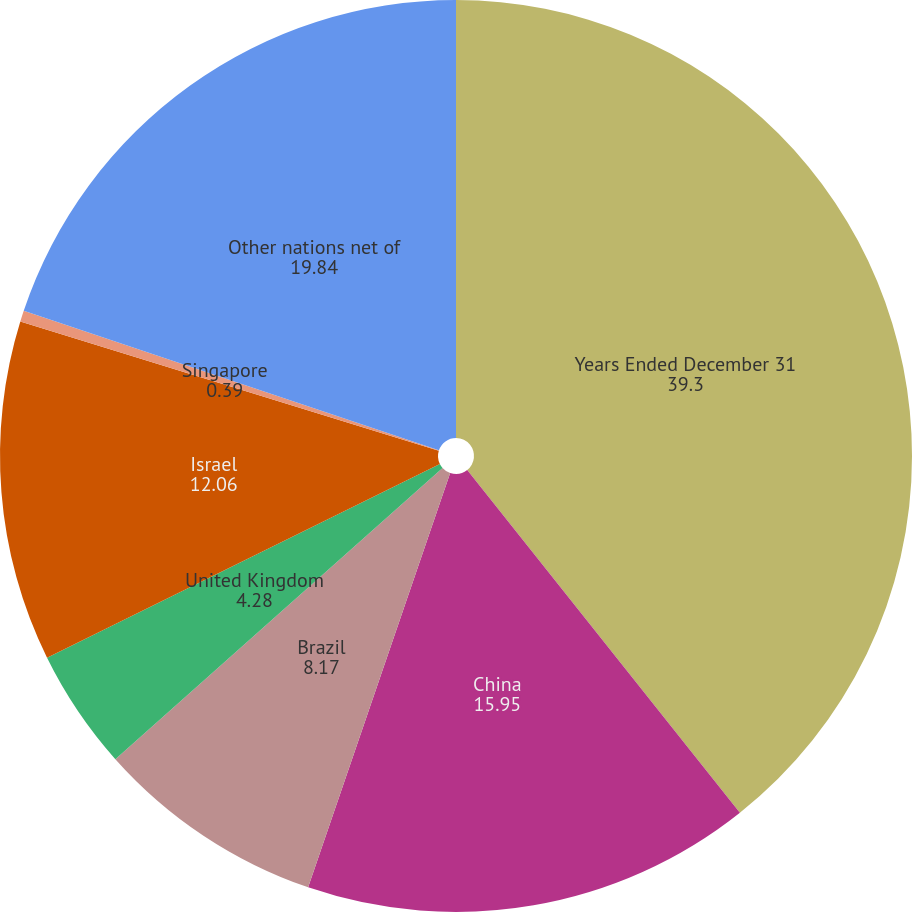Convert chart to OTSL. <chart><loc_0><loc_0><loc_500><loc_500><pie_chart><fcel>Years Ended December 31<fcel>China<fcel>Brazil<fcel>United Kingdom<fcel>Israel<fcel>Singapore<fcel>Other nations net of<nl><fcel>39.3%<fcel>15.95%<fcel>8.17%<fcel>4.28%<fcel>12.06%<fcel>0.39%<fcel>19.84%<nl></chart> 